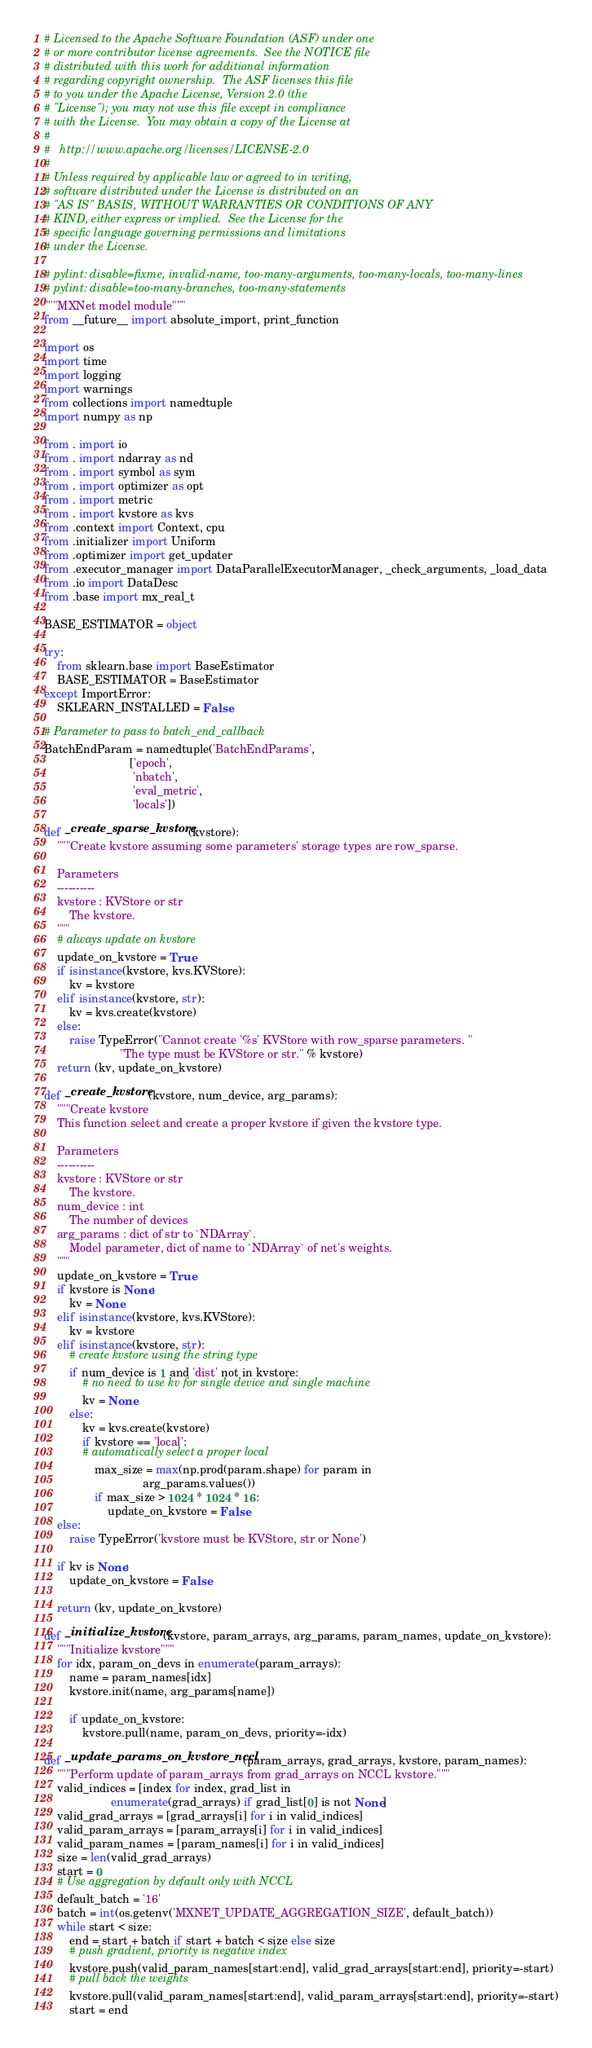<code> <loc_0><loc_0><loc_500><loc_500><_Python_># Licensed to the Apache Software Foundation (ASF) under one
# or more contributor license agreements.  See the NOTICE file
# distributed with this work for additional information
# regarding copyright ownership.  The ASF licenses this file
# to you under the Apache License, Version 2.0 (the
# "License"); you may not use this file except in compliance
# with the License.  You may obtain a copy of the License at
#
#   http://www.apache.org/licenses/LICENSE-2.0
#
# Unless required by applicable law or agreed to in writing,
# software distributed under the License is distributed on an
# "AS IS" BASIS, WITHOUT WARRANTIES OR CONDITIONS OF ANY
# KIND, either express or implied.  See the License for the
# specific language governing permissions and limitations
# under the License.

# pylint: disable=fixme, invalid-name, too-many-arguments, too-many-locals, too-many-lines
# pylint: disable=too-many-branches, too-many-statements
"""MXNet model module"""
from __future__ import absolute_import, print_function

import os
import time
import logging
import warnings
from collections import namedtuple
import numpy as np

from . import io
from . import ndarray as nd
from . import symbol as sym
from . import optimizer as opt
from . import metric
from . import kvstore as kvs
from .context import Context, cpu
from .initializer import Uniform
from .optimizer import get_updater
from .executor_manager import DataParallelExecutorManager, _check_arguments, _load_data
from .io import DataDesc
from .base import mx_real_t

BASE_ESTIMATOR = object

try:
    from sklearn.base import BaseEstimator
    BASE_ESTIMATOR = BaseEstimator
except ImportError:
    SKLEARN_INSTALLED = False

# Parameter to pass to batch_end_callback
BatchEndParam = namedtuple('BatchEndParams',
                           ['epoch',
                            'nbatch',
                            'eval_metric',
                            'locals'])

def _create_sparse_kvstore(kvstore):
    """Create kvstore assuming some parameters' storage types are row_sparse.

    Parameters
    ----------
    kvstore : KVStore or str
        The kvstore.
    """
    # always update on kvstore
    update_on_kvstore = True
    if isinstance(kvstore, kvs.KVStore):
        kv = kvstore
    elif isinstance(kvstore, str):
        kv = kvs.create(kvstore)
    else:
        raise TypeError("Cannot create '%s' KVStore with row_sparse parameters. "
                        "The type must be KVStore or str." % kvstore)
    return (kv, update_on_kvstore)

def _create_kvstore(kvstore, num_device, arg_params):
    """Create kvstore
    This function select and create a proper kvstore if given the kvstore type.

    Parameters
    ----------
    kvstore : KVStore or str
        The kvstore.
    num_device : int
        The number of devices
    arg_params : dict of str to `NDArray`.
        Model parameter, dict of name to `NDArray` of net's weights.
    """
    update_on_kvstore = True
    if kvstore is None:
        kv = None
    elif isinstance(kvstore, kvs.KVStore):
        kv = kvstore
    elif isinstance(kvstore, str):
        # create kvstore using the string type
        if num_device is 1 and 'dist' not in kvstore:
            # no need to use kv for single device and single machine
            kv = None
        else:
            kv = kvs.create(kvstore)
            if kvstore == 'local':
            # automatically select a proper local
                max_size = max(np.prod(param.shape) for param in
                               arg_params.values())
                if max_size > 1024 * 1024 * 16:
                    update_on_kvstore = False
    else:
        raise TypeError('kvstore must be KVStore, str or None')

    if kv is None:
        update_on_kvstore = False

    return (kv, update_on_kvstore)

def _initialize_kvstore(kvstore, param_arrays, arg_params, param_names, update_on_kvstore):
    """Initialize kvstore"""
    for idx, param_on_devs in enumerate(param_arrays):
        name = param_names[idx]
        kvstore.init(name, arg_params[name])

        if update_on_kvstore:
            kvstore.pull(name, param_on_devs, priority=-idx)

def _update_params_on_kvstore_nccl(param_arrays, grad_arrays, kvstore, param_names):
    """Perform update of param_arrays from grad_arrays on NCCL kvstore."""
    valid_indices = [index for index, grad_list in
                     enumerate(grad_arrays) if grad_list[0] is not None]
    valid_grad_arrays = [grad_arrays[i] for i in valid_indices]
    valid_param_arrays = [param_arrays[i] for i in valid_indices]
    valid_param_names = [param_names[i] for i in valid_indices]
    size = len(valid_grad_arrays)
    start = 0
    # Use aggregation by default only with NCCL
    default_batch = '16'
    batch = int(os.getenv('MXNET_UPDATE_AGGREGATION_SIZE', default_batch))
    while start < size:
        end = start + batch if start + batch < size else size
        # push gradient, priority is negative index
        kvstore.push(valid_param_names[start:end], valid_grad_arrays[start:end], priority=-start)
        # pull back the weights
        kvstore.pull(valid_param_names[start:end], valid_param_arrays[start:end], priority=-start)
        start = end
</code> 